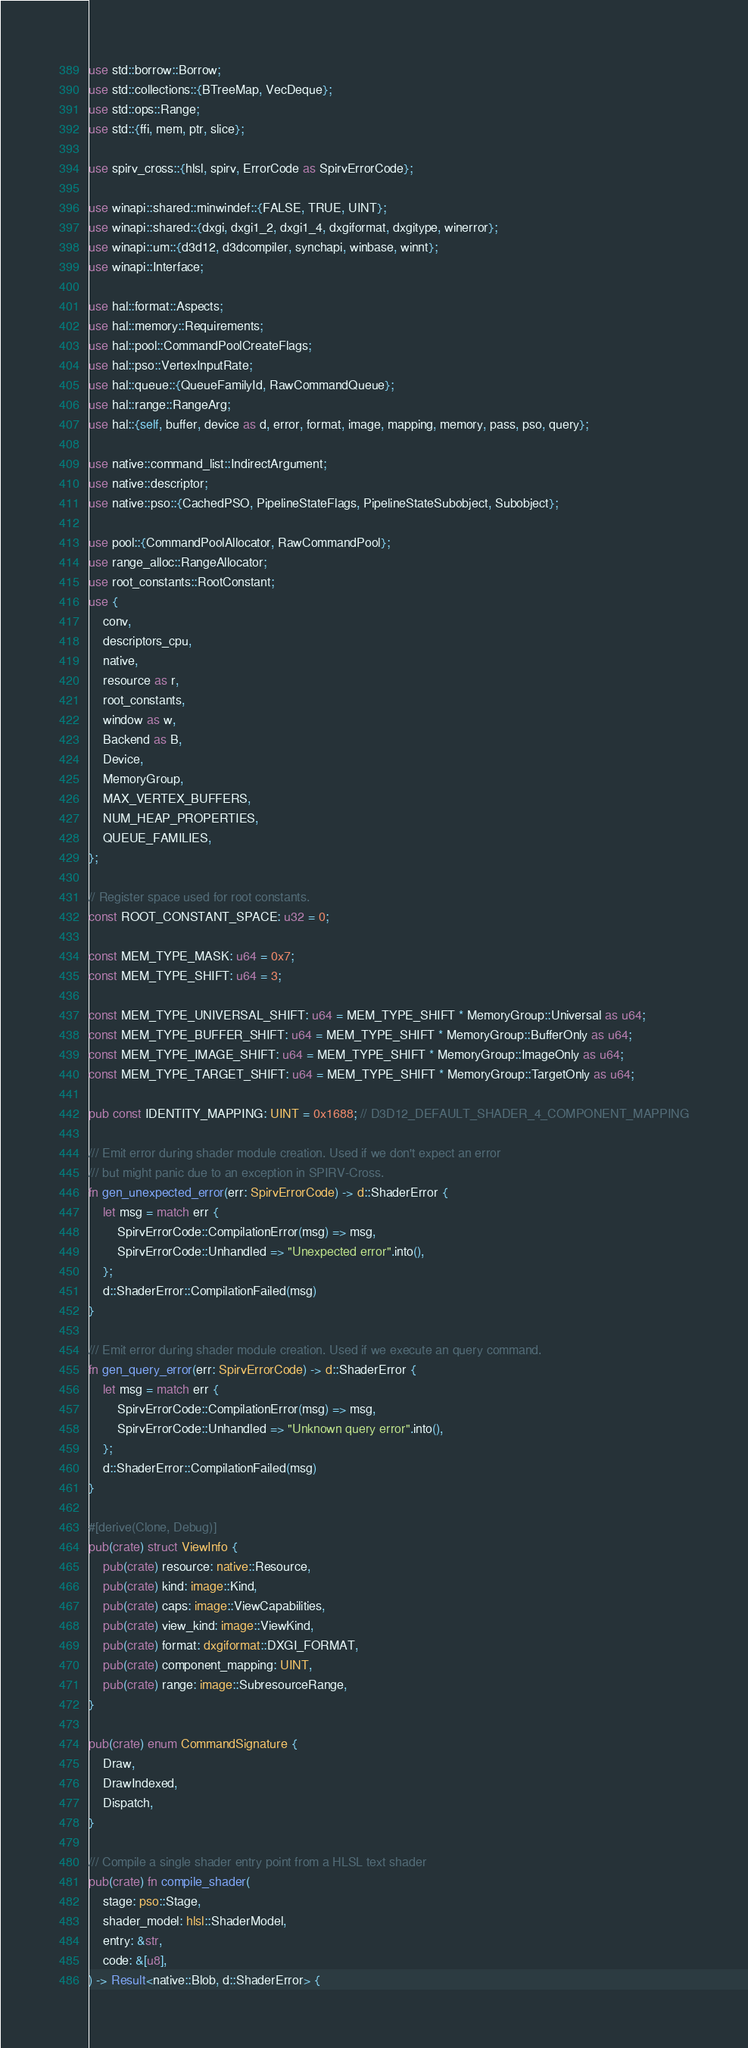Convert code to text. <code><loc_0><loc_0><loc_500><loc_500><_Rust_>use std::borrow::Borrow;
use std::collections::{BTreeMap, VecDeque};
use std::ops::Range;
use std::{ffi, mem, ptr, slice};

use spirv_cross::{hlsl, spirv, ErrorCode as SpirvErrorCode};

use winapi::shared::minwindef::{FALSE, TRUE, UINT};
use winapi::shared::{dxgi, dxgi1_2, dxgi1_4, dxgiformat, dxgitype, winerror};
use winapi::um::{d3d12, d3dcompiler, synchapi, winbase, winnt};
use winapi::Interface;

use hal::format::Aspects;
use hal::memory::Requirements;
use hal::pool::CommandPoolCreateFlags;
use hal::pso::VertexInputRate;
use hal::queue::{QueueFamilyId, RawCommandQueue};
use hal::range::RangeArg;
use hal::{self, buffer, device as d, error, format, image, mapping, memory, pass, pso, query};

use native::command_list::IndirectArgument;
use native::descriptor;
use native::pso::{CachedPSO, PipelineStateFlags, PipelineStateSubobject, Subobject};

use pool::{CommandPoolAllocator, RawCommandPool};
use range_alloc::RangeAllocator;
use root_constants::RootConstant;
use {
    conv,
    descriptors_cpu,
    native,
    resource as r,
    root_constants,
    window as w,
    Backend as B,
    Device,
    MemoryGroup,
    MAX_VERTEX_BUFFERS,
    NUM_HEAP_PROPERTIES,
    QUEUE_FAMILIES,
};

// Register space used for root constants.
const ROOT_CONSTANT_SPACE: u32 = 0;

const MEM_TYPE_MASK: u64 = 0x7;
const MEM_TYPE_SHIFT: u64 = 3;

const MEM_TYPE_UNIVERSAL_SHIFT: u64 = MEM_TYPE_SHIFT * MemoryGroup::Universal as u64;
const MEM_TYPE_BUFFER_SHIFT: u64 = MEM_TYPE_SHIFT * MemoryGroup::BufferOnly as u64;
const MEM_TYPE_IMAGE_SHIFT: u64 = MEM_TYPE_SHIFT * MemoryGroup::ImageOnly as u64;
const MEM_TYPE_TARGET_SHIFT: u64 = MEM_TYPE_SHIFT * MemoryGroup::TargetOnly as u64;

pub const IDENTITY_MAPPING: UINT = 0x1688; // D3D12_DEFAULT_SHADER_4_COMPONENT_MAPPING

/// Emit error during shader module creation. Used if we don't expect an error
/// but might panic due to an exception in SPIRV-Cross.
fn gen_unexpected_error(err: SpirvErrorCode) -> d::ShaderError {
    let msg = match err {
        SpirvErrorCode::CompilationError(msg) => msg,
        SpirvErrorCode::Unhandled => "Unexpected error".into(),
    };
    d::ShaderError::CompilationFailed(msg)
}

/// Emit error during shader module creation. Used if we execute an query command.
fn gen_query_error(err: SpirvErrorCode) -> d::ShaderError {
    let msg = match err {
        SpirvErrorCode::CompilationError(msg) => msg,
        SpirvErrorCode::Unhandled => "Unknown query error".into(),
    };
    d::ShaderError::CompilationFailed(msg)
}

#[derive(Clone, Debug)]
pub(crate) struct ViewInfo {
    pub(crate) resource: native::Resource,
    pub(crate) kind: image::Kind,
    pub(crate) caps: image::ViewCapabilities,
    pub(crate) view_kind: image::ViewKind,
    pub(crate) format: dxgiformat::DXGI_FORMAT,
    pub(crate) component_mapping: UINT,
    pub(crate) range: image::SubresourceRange,
}

pub(crate) enum CommandSignature {
    Draw,
    DrawIndexed,
    Dispatch,
}

/// Compile a single shader entry point from a HLSL text shader
pub(crate) fn compile_shader(
    stage: pso::Stage,
    shader_model: hlsl::ShaderModel,
    entry: &str,
    code: &[u8],
) -> Result<native::Blob, d::ShaderError> {</code> 